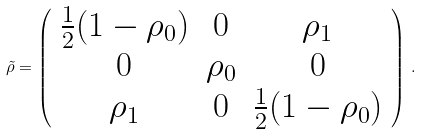Convert formula to latex. <formula><loc_0><loc_0><loc_500><loc_500>\tilde { \rho } = \left ( \begin{array} { c c c } \frac { 1 } { 2 } ( 1 - \rho _ { 0 } ) & 0 & \rho _ { 1 } \\ 0 & \rho _ { 0 } & 0 \\ \rho _ { 1 } & 0 & \frac { 1 } { 2 } ( 1 - \rho _ { 0 } ) \end{array} \right ) \, .</formula> 